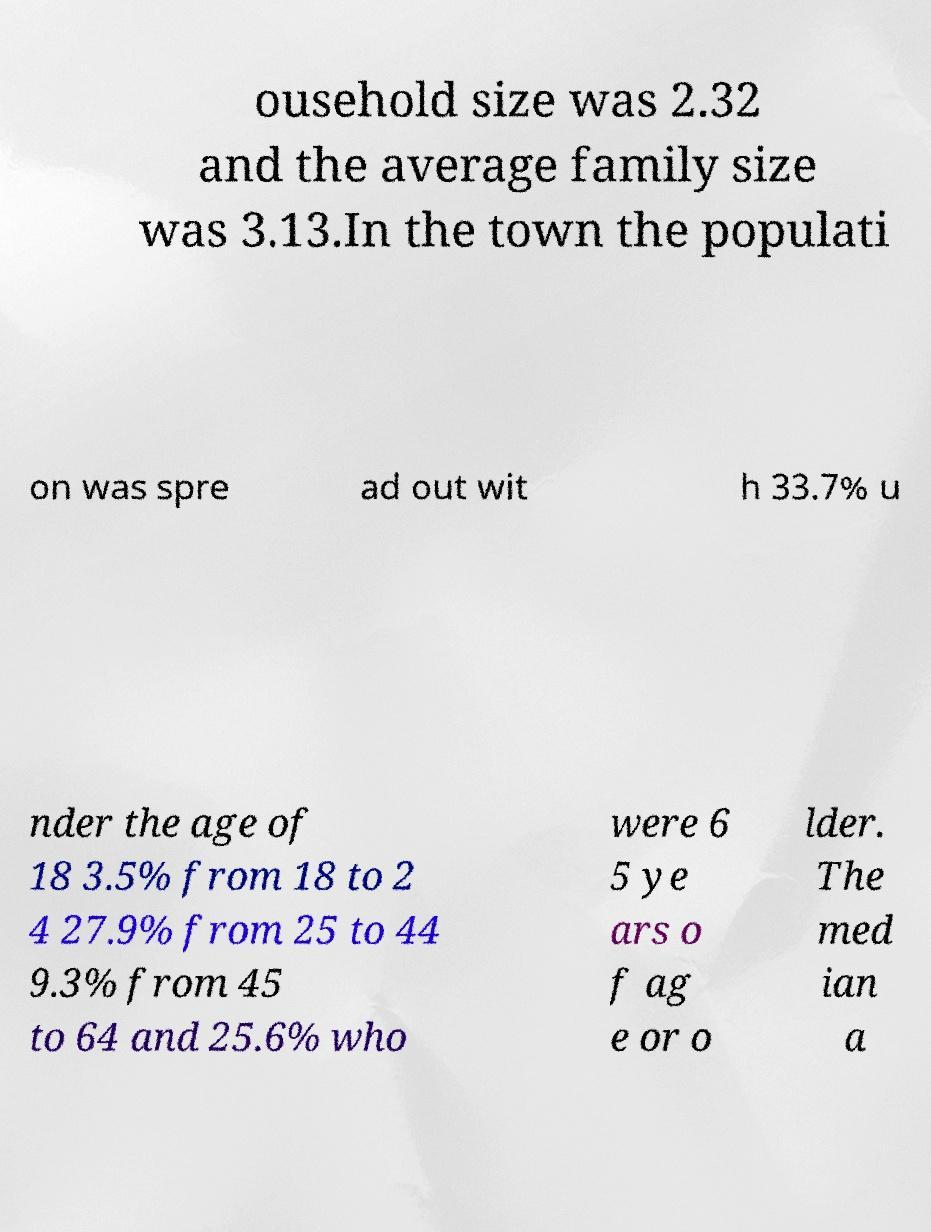There's text embedded in this image that I need extracted. Can you transcribe it verbatim? ousehold size was 2.32 and the average family size was 3.13.In the town the populati on was spre ad out wit h 33.7% u nder the age of 18 3.5% from 18 to 2 4 27.9% from 25 to 44 9.3% from 45 to 64 and 25.6% who were 6 5 ye ars o f ag e or o lder. The med ian a 